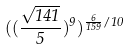<formula> <loc_0><loc_0><loc_500><loc_500>( ( \frac { \sqrt { 1 4 1 } } { 5 } ) ^ { 9 } ) ^ { \frac { 6 } { 1 5 9 } / 1 0 }</formula> 